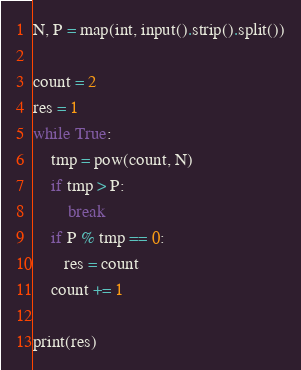Convert code to text. <code><loc_0><loc_0><loc_500><loc_500><_Python_>N, P = map(int, input().strip().split())

count = 2
res = 1
while True:
    tmp = pow(count, N)
    if tmp > P:
        break
    if P % tmp == 0:
       res = count
    count += 1

print(res)</code> 